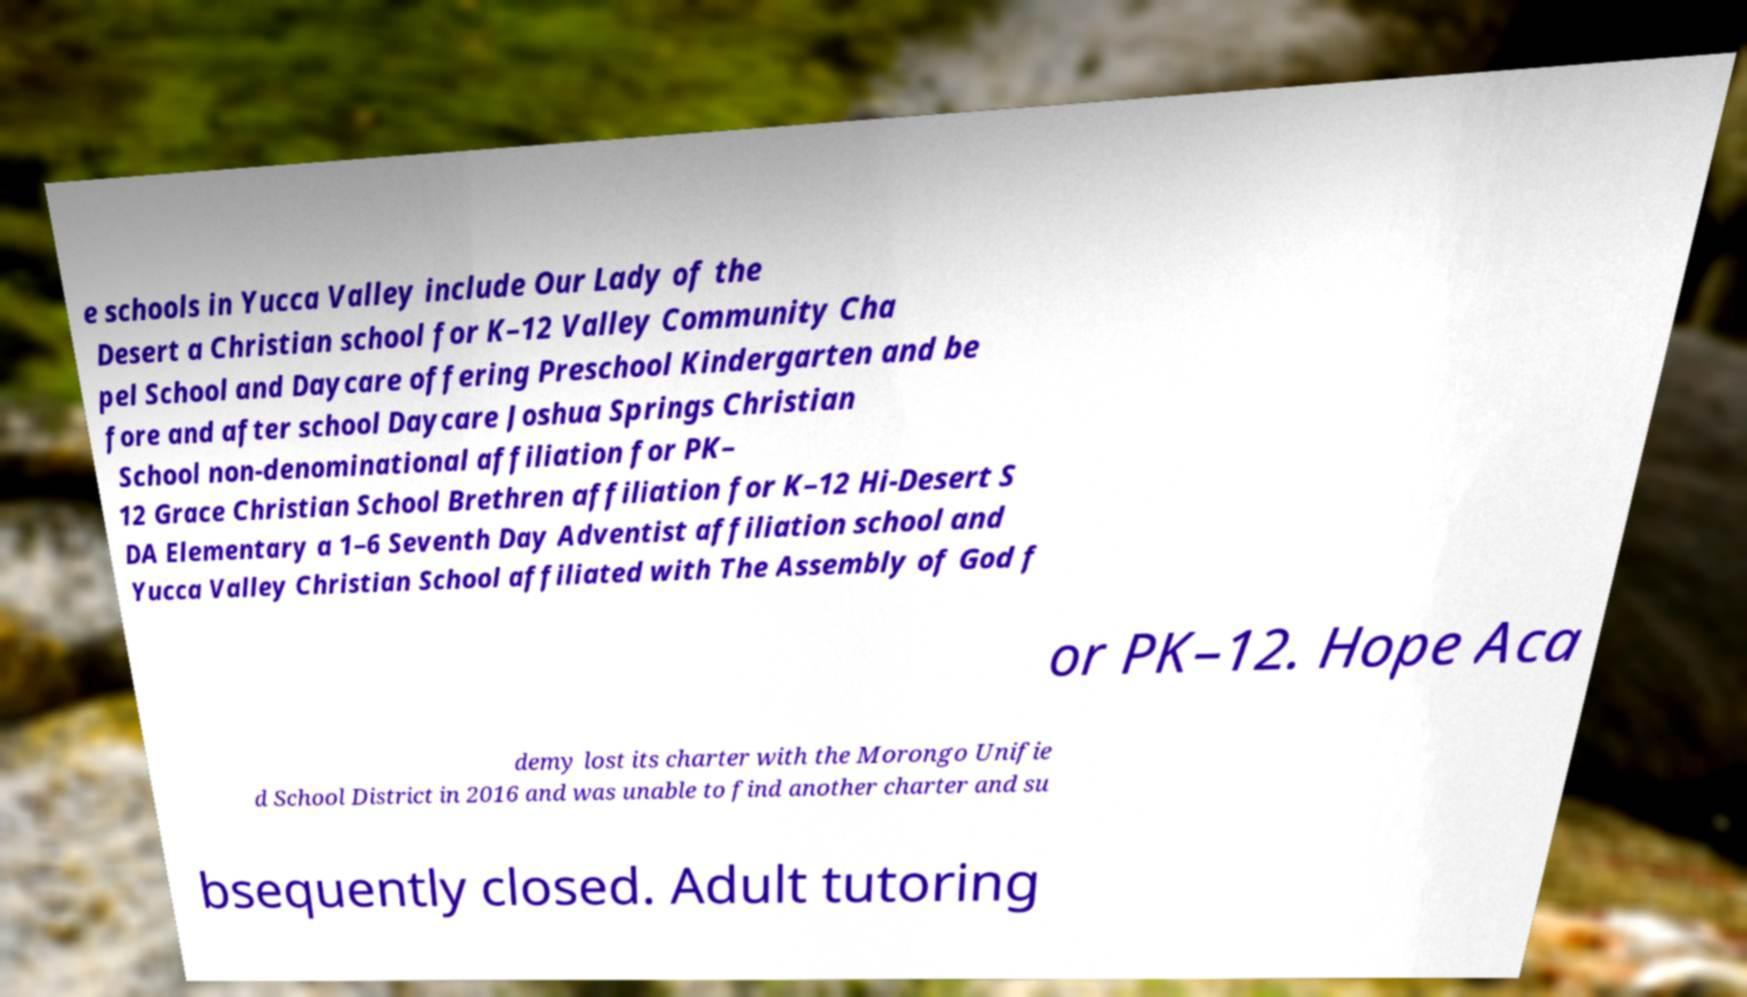What messages or text are displayed in this image? I need them in a readable, typed format. e schools in Yucca Valley include Our Lady of the Desert a Christian school for K–12 Valley Community Cha pel School and Daycare offering Preschool Kindergarten and be fore and after school Daycare Joshua Springs Christian School non-denominational affiliation for PK– 12 Grace Christian School Brethren affiliation for K–12 Hi-Desert S DA Elementary a 1–6 Seventh Day Adventist affiliation school and Yucca Valley Christian School affiliated with The Assembly of God f or PK–12. Hope Aca demy lost its charter with the Morongo Unifie d School District in 2016 and was unable to find another charter and su bsequently closed. Adult tutoring 